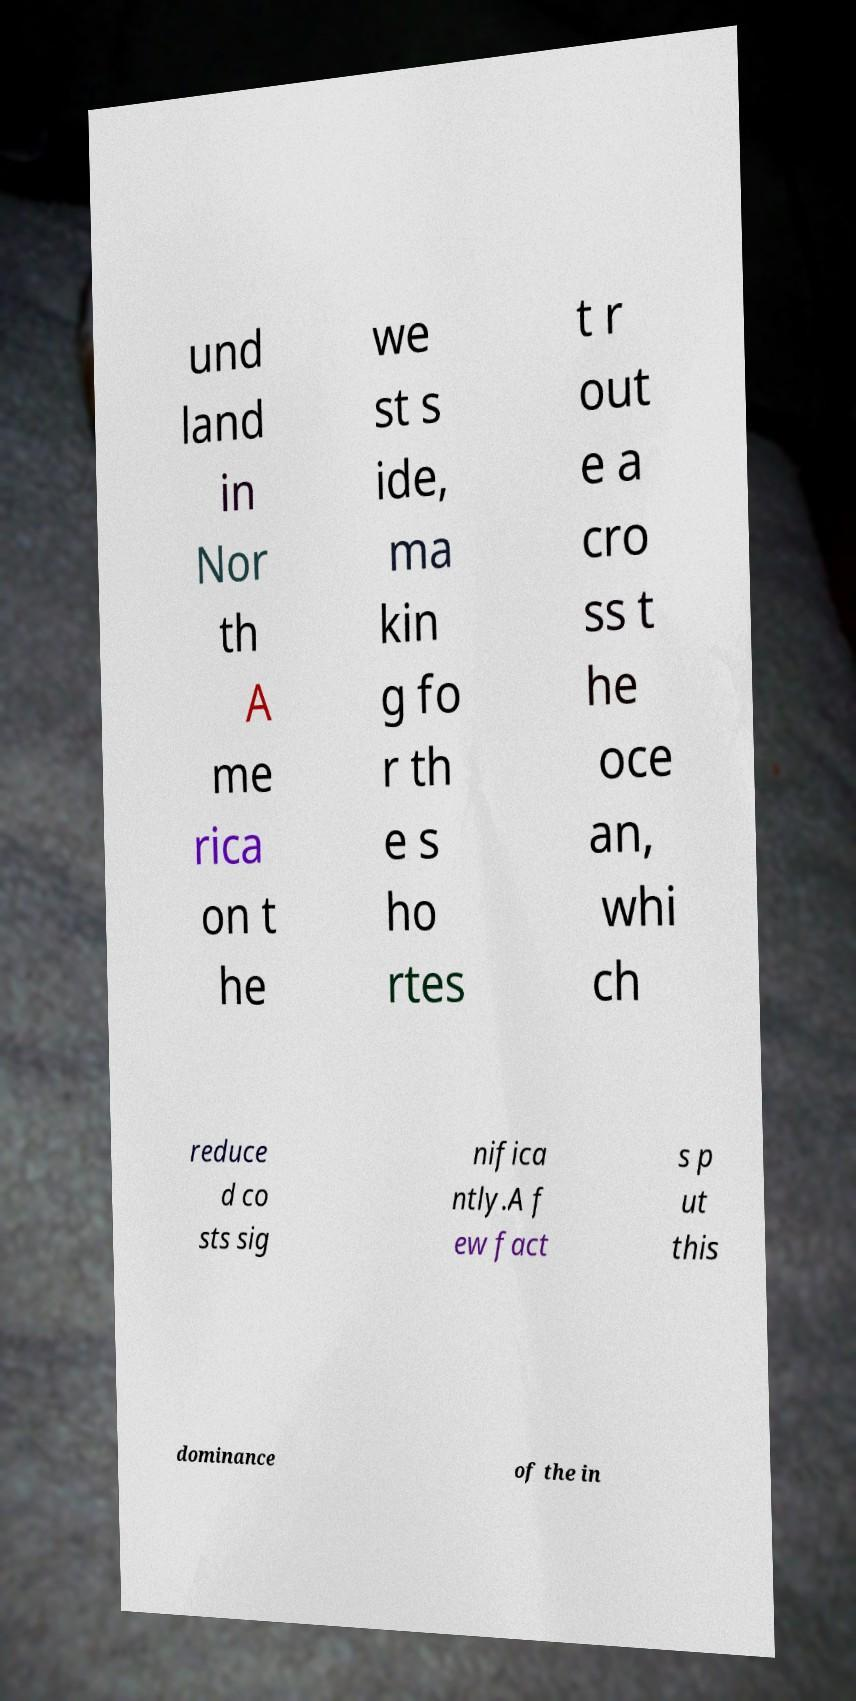Could you extract and type out the text from this image? und land in Nor th A me rica on t he we st s ide, ma kin g fo r th e s ho rtes t r out e a cro ss t he oce an, whi ch reduce d co sts sig nifica ntly.A f ew fact s p ut this dominance of the in 